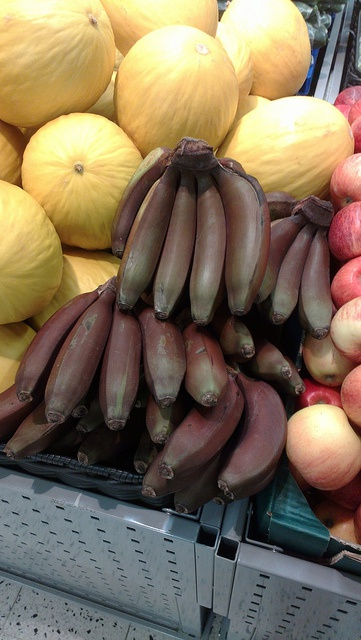Describe the objects in this image and their specific colors. I can see banana in khaki, black, gray, and maroon tones, banana in khaki, gray, black, and maroon tones, banana in khaki, black, brown, and maroon tones, banana in khaki, gray, maroon, and black tones, and apple in khaki, tan, brown, and lightyellow tones in this image. 